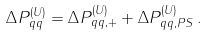<formula> <loc_0><loc_0><loc_500><loc_500>\Delta P _ { q q } ^ { ( U ) } = \Delta P _ { q q , + } ^ { ( U ) } + \Delta P _ { q q , P S } ^ { ( U ) } \, .</formula> 